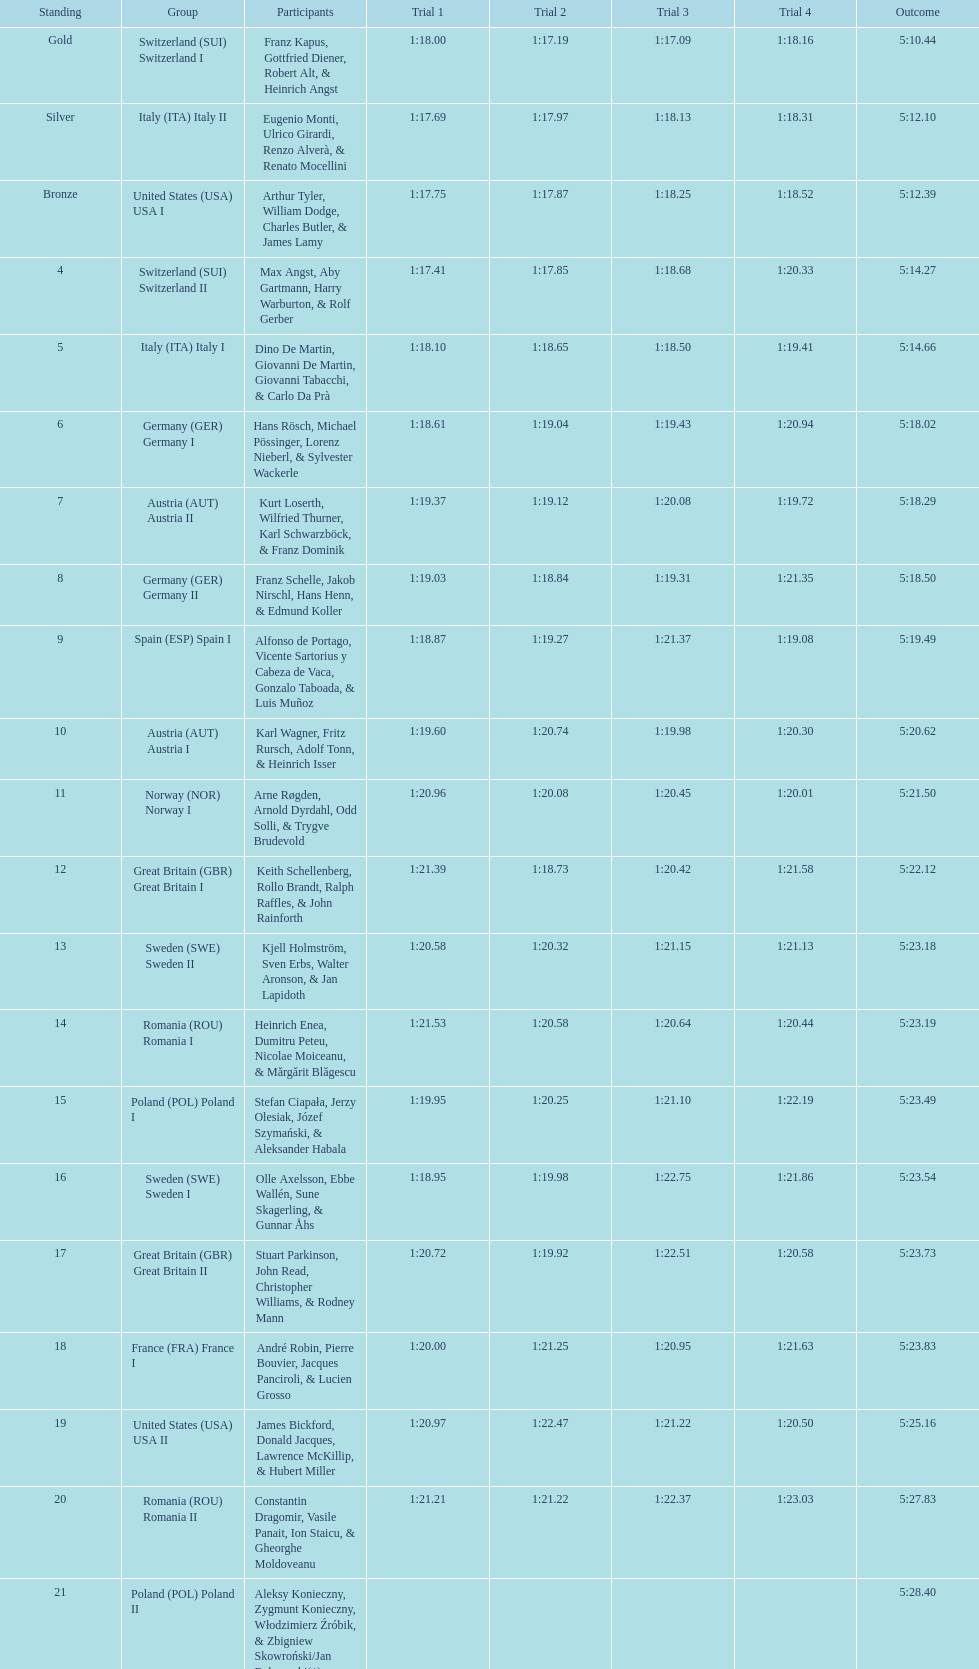Which team won the most runs? Switzerland. 